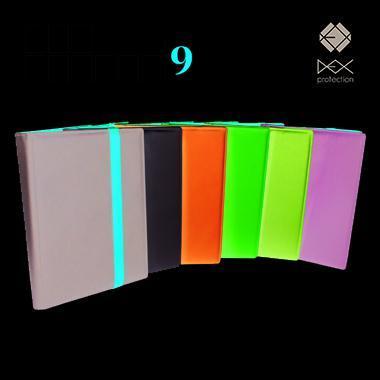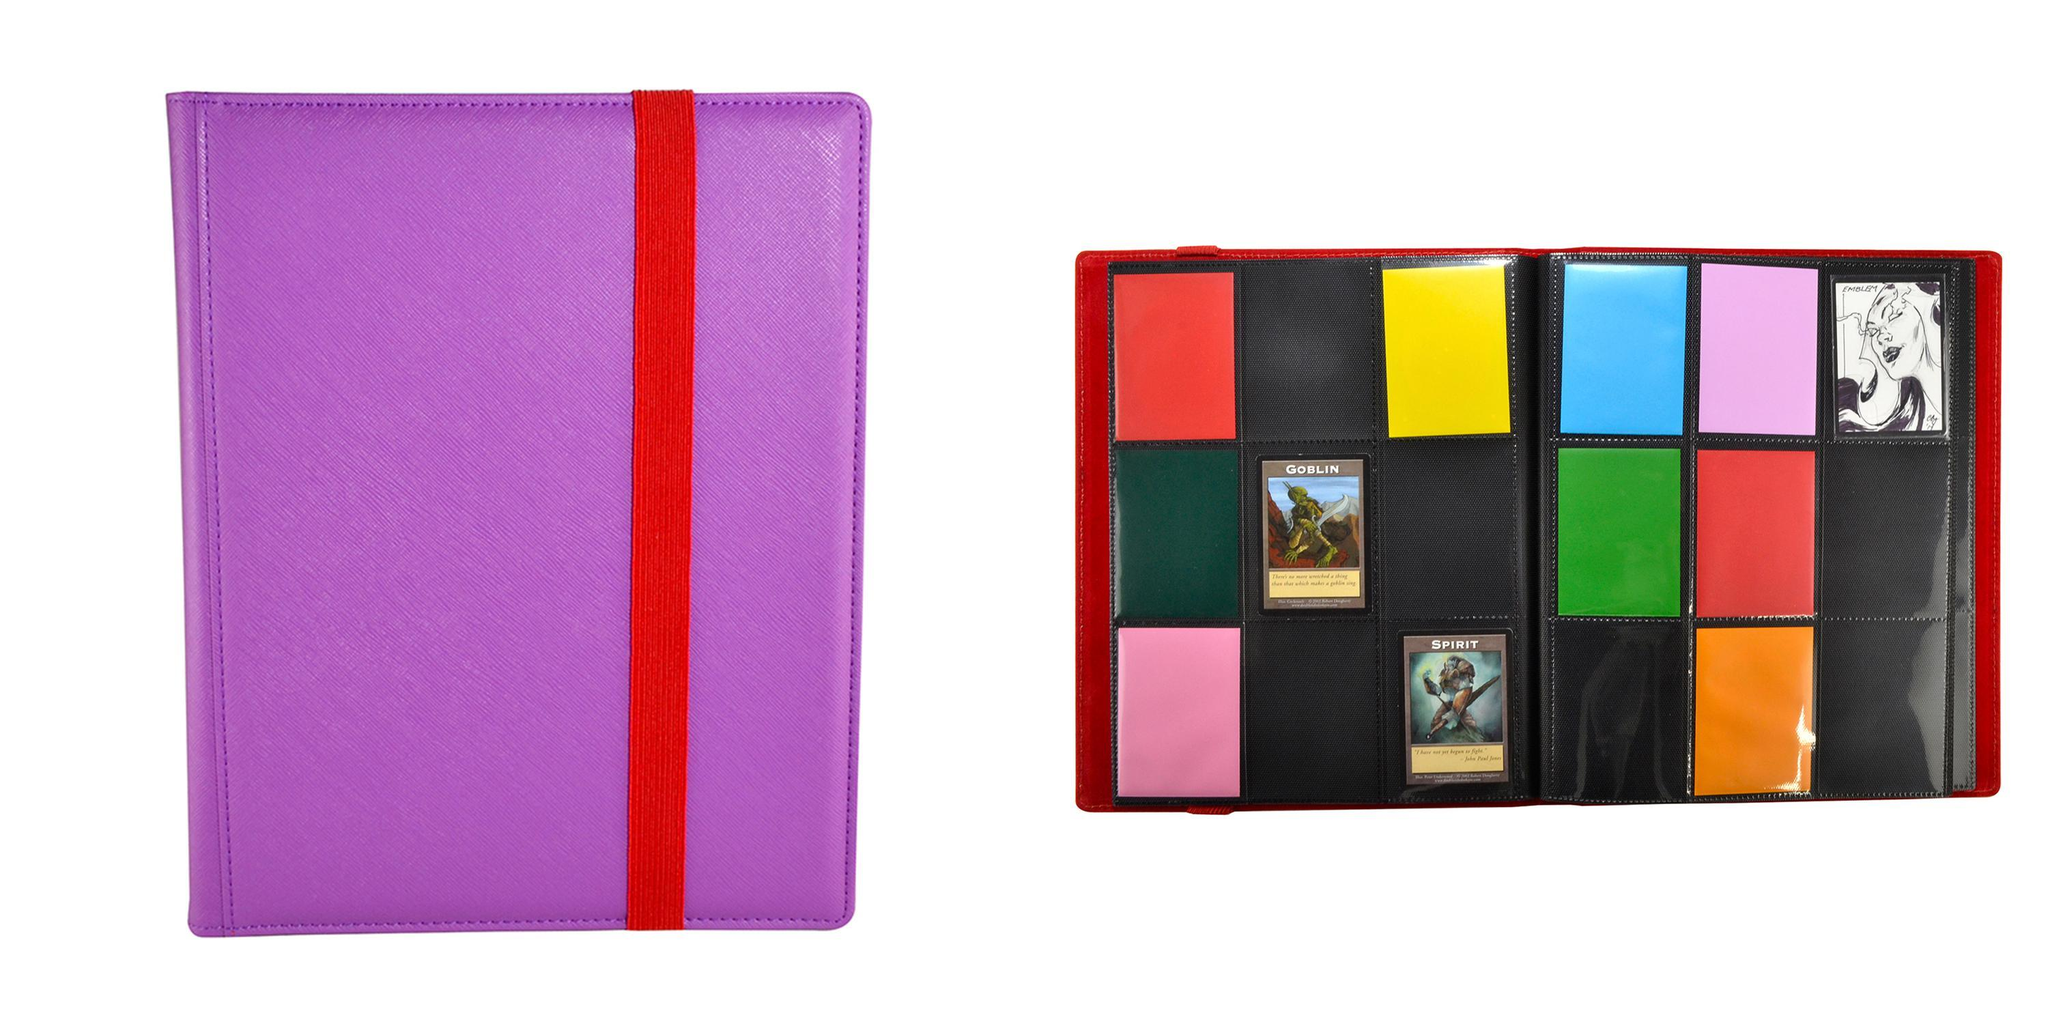The first image is the image on the left, the second image is the image on the right. Evaluate the accuracy of this statement regarding the images: "An image depicts a purple binder next to an open binder.". Is it true? Answer yes or no. Yes. 